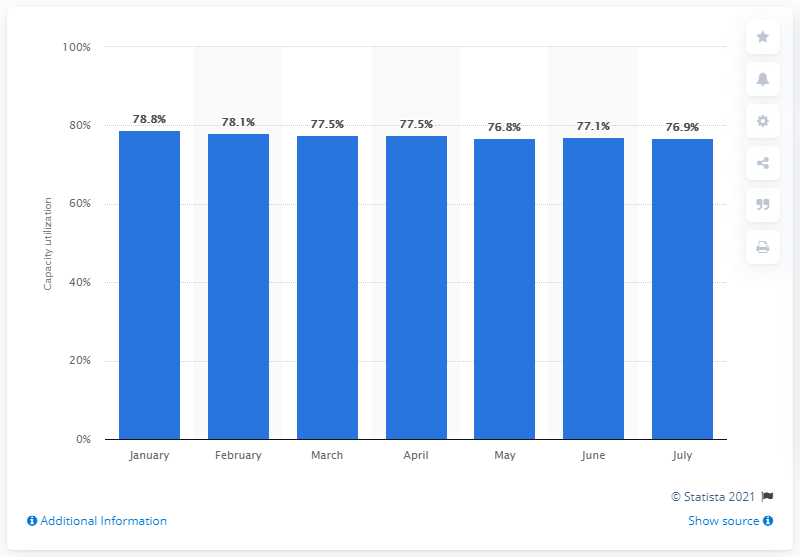Draw attention to some important aspects in this diagram. In January 2012, the capacity utilization of the chemical industry in the United States was 78.1%. 